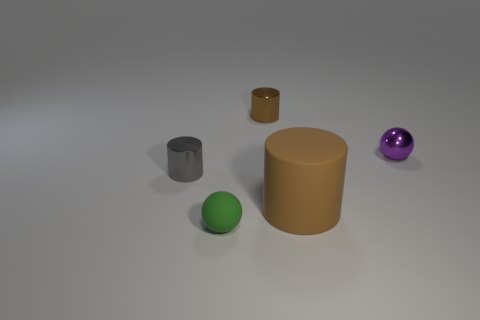Subtract all brown cylinders. How many cylinders are left? 1 Add 1 shiny objects. How many objects exist? 6 Subtract all balls. How many objects are left? 3 Subtract all purple spheres. How many spheres are left? 1 Subtract 2 balls. How many balls are left? 0 Subtract all green cylinders. Subtract all blue blocks. How many cylinders are left? 3 Subtract all green cylinders. How many green balls are left? 1 Subtract all green matte things. Subtract all small green metal cylinders. How many objects are left? 4 Add 4 small brown shiny cylinders. How many small brown shiny cylinders are left? 5 Add 5 tiny gray metallic things. How many tiny gray metallic things exist? 6 